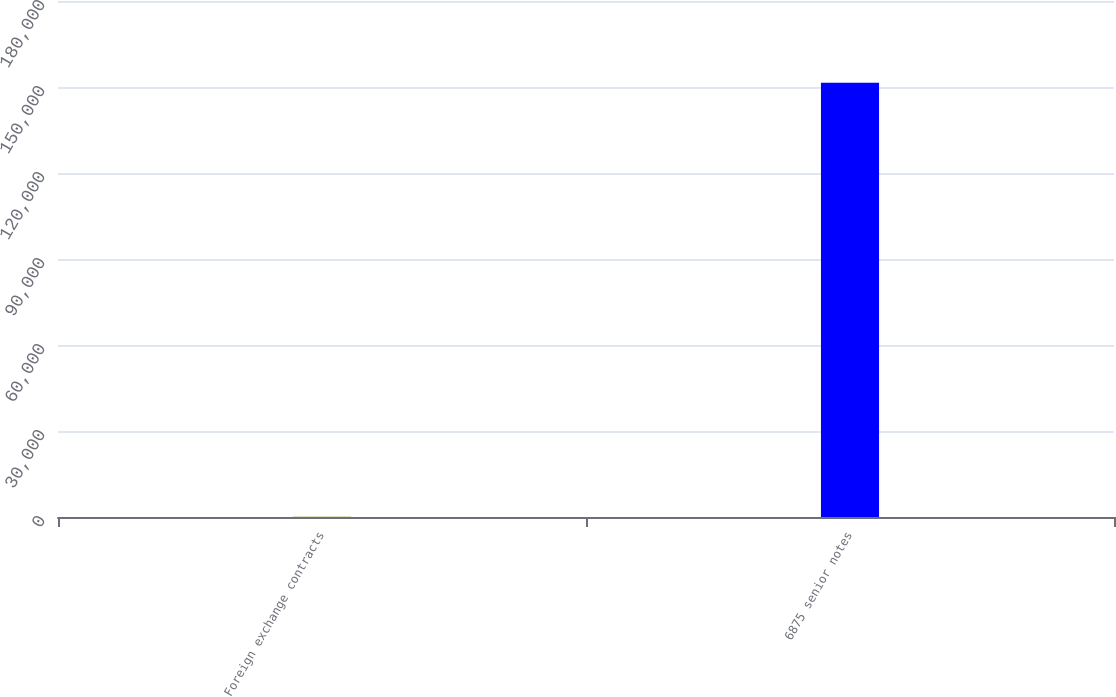Convert chart to OTSL. <chart><loc_0><loc_0><loc_500><loc_500><bar_chart><fcel>Foreign exchange contracts<fcel>6875 senior notes<nl><fcel>110<fcel>151500<nl></chart> 